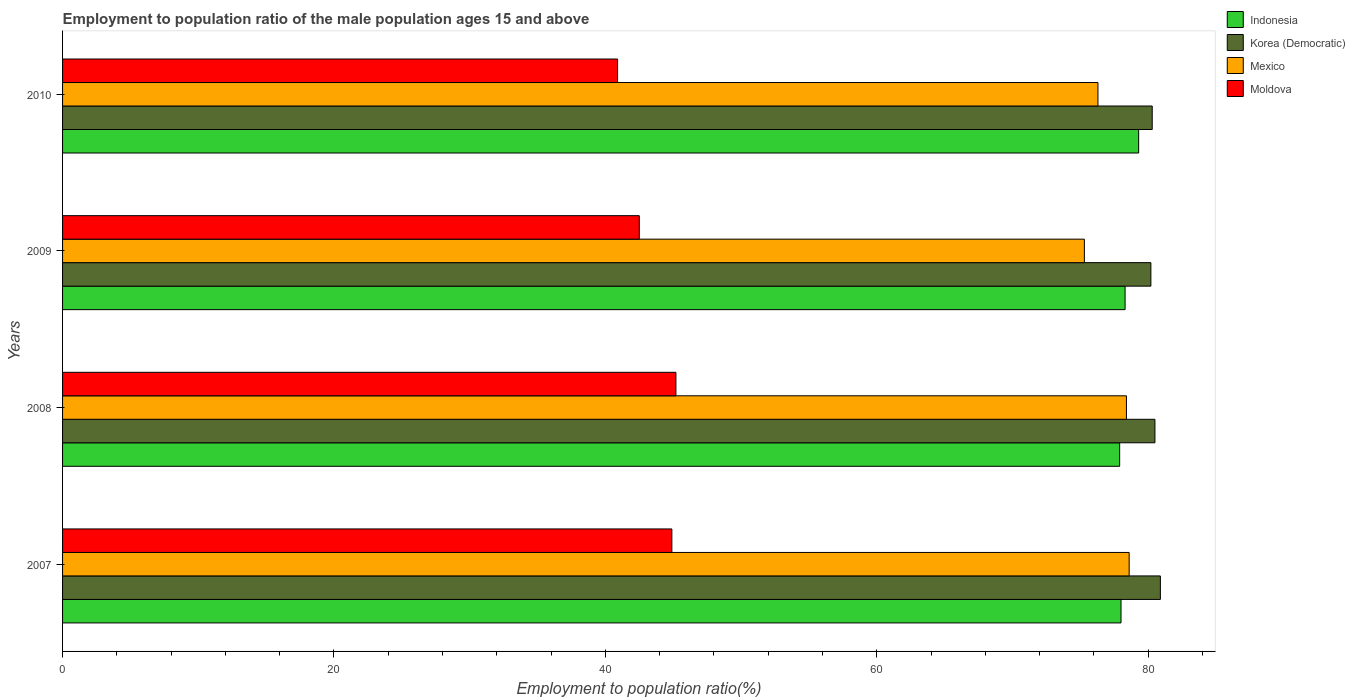How many different coloured bars are there?
Ensure brevity in your answer.  4. How many groups of bars are there?
Make the answer very short. 4. Are the number of bars per tick equal to the number of legend labels?
Give a very brief answer. Yes. Are the number of bars on each tick of the Y-axis equal?
Offer a terse response. Yes. How many bars are there on the 4th tick from the top?
Your answer should be compact. 4. How many bars are there on the 1st tick from the bottom?
Give a very brief answer. 4. In how many cases, is the number of bars for a given year not equal to the number of legend labels?
Make the answer very short. 0. What is the employment to population ratio in Indonesia in 2010?
Make the answer very short. 79.3. Across all years, what is the maximum employment to population ratio in Indonesia?
Ensure brevity in your answer.  79.3. Across all years, what is the minimum employment to population ratio in Mexico?
Provide a short and direct response. 75.3. In which year was the employment to population ratio in Korea (Democratic) maximum?
Your response must be concise. 2007. What is the total employment to population ratio in Moldova in the graph?
Offer a very short reply. 173.5. What is the difference between the employment to population ratio in Korea (Democratic) in 2007 and that in 2009?
Your answer should be compact. 0.7. What is the difference between the employment to population ratio in Mexico in 2010 and the employment to population ratio in Moldova in 2009?
Make the answer very short. 33.8. What is the average employment to population ratio in Mexico per year?
Make the answer very short. 77.15. In the year 2008, what is the difference between the employment to population ratio in Indonesia and employment to population ratio in Mexico?
Offer a terse response. -0.5. What is the ratio of the employment to population ratio in Moldova in 2008 to that in 2009?
Ensure brevity in your answer.  1.06. Is the difference between the employment to population ratio in Indonesia in 2007 and 2008 greater than the difference between the employment to population ratio in Mexico in 2007 and 2008?
Provide a short and direct response. No. What is the difference between the highest and the second highest employment to population ratio in Korea (Democratic)?
Give a very brief answer. 0.4. What is the difference between the highest and the lowest employment to population ratio in Moldova?
Your response must be concise. 4.3. What does the 1st bar from the top in 2007 represents?
Offer a very short reply. Moldova. What does the 3rd bar from the bottom in 2010 represents?
Your answer should be compact. Mexico. How many bars are there?
Give a very brief answer. 16. Are all the bars in the graph horizontal?
Offer a very short reply. Yes. What is the difference between two consecutive major ticks on the X-axis?
Your answer should be very brief. 20. Where does the legend appear in the graph?
Offer a very short reply. Top right. How many legend labels are there?
Keep it short and to the point. 4. How are the legend labels stacked?
Offer a very short reply. Vertical. What is the title of the graph?
Give a very brief answer. Employment to population ratio of the male population ages 15 and above. What is the label or title of the Y-axis?
Provide a short and direct response. Years. What is the Employment to population ratio(%) in Indonesia in 2007?
Offer a terse response. 78. What is the Employment to population ratio(%) of Korea (Democratic) in 2007?
Offer a terse response. 80.9. What is the Employment to population ratio(%) of Mexico in 2007?
Ensure brevity in your answer.  78.6. What is the Employment to population ratio(%) of Moldova in 2007?
Provide a short and direct response. 44.9. What is the Employment to population ratio(%) in Indonesia in 2008?
Ensure brevity in your answer.  77.9. What is the Employment to population ratio(%) in Korea (Democratic) in 2008?
Ensure brevity in your answer.  80.5. What is the Employment to population ratio(%) of Mexico in 2008?
Make the answer very short. 78.4. What is the Employment to population ratio(%) of Moldova in 2008?
Provide a succinct answer. 45.2. What is the Employment to population ratio(%) of Indonesia in 2009?
Offer a very short reply. 78.3. What is the Employment to population ratio(%) of Korea (Democratic) in 2009?
Offer a very short reply. 80.2. What is the Employment to population ratio(%) in Mexico in 2009?
Provide a short and direct response. 75.3. What is the Employment to population ratio(%) of Moldova in 2009?
Offer a terse response. 42.5. What is the Employment to population ratio(%) of Indonesia in 2010?
Your response must be concise. 79.3. What is the Employment to population ratio(%) in Korea (Democratic) in 2010?
Your answer should be compact. 80.3. What is the Employment to population ratio(%) in Mexico in 2010?
Keep it short and to the point. 76.3. What is the Employment to population ratio(%) in Moldova in 2010?
Ensure brevity in your answer.  40.9. Across all years, what is the maximum Employment to population ratio(%) in Indonesia?
Make the answer very short. 79.3. Across all years, what is the maximum Employment to population ratio(%) of Korea (Democratic)?
Your answer should be compact. 80.9. Across all years, what is the maximum Employment to population ratio(%) in Mexico?
Your answer should be very brief. 78.6. Across all years, what is the maximum Employment to population ratio(%) of Moldova?
Your answer should be very brief. 45.2. Across all years, what is the minimum Employment to population ratio(%) of Indonesia?
Ensure brevity in your answer.  77.9. Across all years, what is the minimum Employment to population ratio(%) of Korea (Democratic)?
Make the answer very short. 80.2. Across all years, what is the minimum Employment to population ratio(%) in Mexico?
Provide a succinct answer. 75.3. Across all years, what is the minimum Employment to population ratio(%) in Moldova?
Offer a terse response. 40.9. What is the total Employment to population ratio(%) of Indonesia in the graph?
Keep it short and to the point. 313.5. What is the total Employment to population ratio(%) in Korea (Democratic) in the graph?
Give a very brief answer. 321.9. What is the total Employment to population ratio(%) of Mexico in the graph?
Give a very brief answer. 308.6. What is the total Employment to population ratio(%) of Moldova in the graph?
Your response must be concise. 173.5. What is the difference between the Employment to population ratio(%) in Korea (Democratic) in 2007 and that in 2009?
Offer a very short reply. 0.7. What is the difference between the Employment to population ratio(%) in Mexico in 2007 and that in 2009?
Your answer should be compact. 3.3. What is the difference between the Employment to population ratio(%) of Korea (Democratic) in 2007 and that in 2010?
Your answer should be very brief. 0.6. What is the difference between the Employment to population ratio(%) in Moldova in 2007 and that in 2010?
Provide a short and direct response. 4. What is the difference between the Employment to population ratio(%) of Korea (Democratic) in 2008 and that in 2009?
Provide a short and direct response. 0.3. What is the difference between the Employment to population ratio(%) in Moldova in 2008 and that in 2009?
Keep it short and to the point. 2.7. What is the difference between the Employment to population ratio(%) of Korea (Democratic) in 2008 and that in 2010?
Ensure brevity in your answer.  0.2. What is the difference between the Employment to population ratio(%) of Moldova in 2008 and that in 2010?
Provide a succinct answer. 4.3. What is the difference between the Employment to population ratio(%) in Korea (Democratic) in 2009 and that in 2010?
Offer a terse response. -0.1. What is the difference between the Employment to population ratio(%) in Mexico in 2009 and that in 2010?
Offer a very short reply. -1. What is the difference between the Employment to population ratio(%) of Indonesia in 2007 and the Employment to population ratio(%) of Mexico in 2008?
Your answer should be compact. -0.4. What is the difference between the Employment to population ratio(%) of Indonesia in 2007 and the Employment to population ratio(%) of Moldova in 2008?
Your answer should be compact. 32.8. What is the difference between the Employment to population ratio(%) of Korea (Democratic) in 2007 and the Employment to population ratio(%) of Mexico in 2008?
Your response must be concise. 2.5. What is the difference between the Employment to population ratio(%) of Korea (Democratic) in 2007 and the Employment to population ratio(%) of Moldova in 2008?
Offer a very short reply. 35.7. What is the difference between the Employment to population ratio(%) in Mexico in 2007 and the Employment to population ratio(%) in Moldova in 2008?
Keep it short and to the point. 33.4. What is the difference between the Employment to population ratio(%) of Indonesia in 2007 and the Employment to population ratio(%) of Mexico in 2009?
Your answer should be very brief. 2.7. What is the difference between the Employment to population ratio(%) in Indonesia in 2007 and the Employment to population ratio(%) in Moldova in 2009?
Your answer should be compact. 35.5. What is the difference between the Employment to population ratio(%) in Korea (Democratic) in 2007 and the Employment to population ratio(%) in Moldova in 2009?
Ensure brevity in your answer.  38.4. What is the difference between the Employment to population ratio(%) of Mexico in 2007 and the Employment to population ratio(%) of Moldova in 2009?
Provide a succinct answer. 36.1. What is the difference between the Employment to population ratio(%) of Indonesia in 2007 and the Employment to population ratio(%) of Korea (Democratic) in 2010?
Your response must be concise. -2.3. What is the difference between the Employment to population ratio(%) of Indonesia in 2007 and the Employment to population ratio(%) of Moldova in 2010?
Your answer should be very brief. 37.1. What is the difference between the Employment to population ratio(%) in Mexico in 2007 and the Employment to population ratio(%) in Moldova in 2010?
Your response must be concise. 37.7. What is the difference between the Employment to population ratio(%) in Indonesia in 2008 and the Employment to population ratio(%) in Korea (Democratic) in 2009?
Your answer should be compact. -2.3. What is the difference between the Employment to population ratio(%) in Indonesia in 2008 and the Employment to population ratio(%) in Mexico in 2009?
Offer a terse response. 2.6. What is the difference between the Employment to population ratio(%) in Indonesia in 2008 and the Employment to population ratio(%) in Moldova in 2009?
Ensure brevity in your answer.  35.4. What is the difference between the Employment to population ratio(%) in Korea (Democratic) in 2008 and the Employment to population ratio(%) in Moldova in 2009?
Offer a very short reply. 38. What is the difference between the Employment to population ratio(%) of Mexico in 2008 and the Employment to population ratio(%) of Moldova in 2009?
Your answer should be very brief. 35.9. What is the difference between the Employment to population ratio(%) of Indonesia in 2008 and the Employment to population ratio(%) of Mexico in 2010?
Keep it short and to the point. 1.6. What is the difference between the Employment to population ratio(%) in Indonesia in 2008 and the Employment to population ratio(%) in Moldova in 2010?
Give a very brief answer. 37. What is the difference between the Employment to population ratio(%) in Korea (Democratic) in 2008 and the Employment to population ratio(%) in Mexico in 2010?
Offer a very short reply. 4.2. What is the difference between the Employment to population ratio(%) in Korea (Democratic) in 2008 and the Employment to population ratio(%) in Moldova in 2010?
Provide a succinct answer. 39.6. What is the difference between the Employment to population ratio(%) in Mexico in 2008 and the Employment to population ratio(%) in Moldova in 2010?
Ensure brevity in your answer.  37.5. What is the difference between the Employment to population ratio(%) in Indonesia in 2009 and the Employment to population ratio(%) in Moldova in 2010?
Your answer should be compact. 37.4. What is the difference between the Employment to population ratio(%) of Korea (Democratic) in 2009 and the Employment to population ratio(%) of Mexico in 2010?
Offer a terse response. 3.9. What is the difference between the Employment to population ratio(%) of Korea (Democratic) in 2009 and the Employment to population ratio(%) of Moldova in 2010?
Your answer should be very brief. 39.3. What is the difference between the Employment to population ratio(%) of Mexico in 2009 and the Employment to population ratio(%) of Moldova in 2010?
Offer a very short reply. 34.4. What is the average Employment to population ratio(%) in Indonesia per year?
Provide a short and direct response. 78.38. What is the average Employment to population ratio(%) in Korea (Democratic) per year?
Provide a short and direct response. 80.47. What is the average Employment to population ratio(%) of Mexico per year?
Give a very brief answer. 77.15. What is the average Employment to population ratio(%) of Moldova per year?
Ensure brevity in your answer.  43.38. In the year 2007, what is the difference between the Employment to population ratio(%) in Indonesia and Employment to population ratio(%) in Korea (Democratic)?
Give a very brief answer. -2.9. In the year 2007, what is the difference between the Employment to population ratio(%) in Indonesia and Employment to population ratio(%) in Moldova?
Provide a succinct answer. 33.1. In the year 2007, what is the difference between the Employment to population ratio(%) of Korea (Democratic) and Employment to population ratio(%) of Mexico?
Provide a short and direct response. 2.3. In the year 2007, what is the difference between the Employment to population ratio(%) in Mexico and Employment to population ratio(%) in Moldova?
Offer a terse response. 33.7. In the year 2008, what is the difference between the Employment to population ratio(%) in Indonesia and Employment to population ratio(%) in Mexico?
Provide a succinct answer. -0.5. In the year 2008, what is the difference between the Employment to population ratio(%) of Indonesia and Employment to population ratio(%) of Moldova?
Ensure brevity in your answer.  32.7. In the year 2008, what is the difference between the Employment to population ratio(%) in Korea (Democratic) and Employment to population ratio(%) in Moldova?
Ensure brevity in your answer.  35.3. In the year 2008, what is the difference between the Employment to population ratio(%) in Mexico and Employment to population ratio(%) in Moldova?
Make the answer very short. 33.2. In the year 2009, what is the difference between the Employment to population ratio(%) of Indonesia and Employment to population ratio(%) of Mexico?
Offer a very short reply. 3. In the year 2009, what is the difference between the Employment to population ratio(%) in Indonesia and Employment to population ratio(%) in Moldova?
Keep it short and to the point. 35.8. In the year 2009, what is the difference between the Employment to population ratio(%) of Korea (Democratic) and Employment to population ratio(%) of Moldova?
Offer a terse response. 37.7. In the year 2009, what is the difference between the Employment to population ratio(%) in Mexico and Employment to population ratio(%) in Moldova?
Provide a short and direct response. 32.8. In the year 2010, what is the difference between the Employment to population ratio(%) in Indonesia and Employment to population ratio(%) in Korea (Democratic)?
Give a very brief answer. -1. In the year 2010, what is the difference between the Employment to population ratio(%) of Indonesia and Employment to population ratio(%) of Mexico?
Offer a very short reply. 3. In the year 2010, what is the difference between the Employment to population ratio(%) in Indonesia and Employment to population ratio(%) in Moldova?
Ensure brevity in your answer.  38.4. In the year 2010, what is the difference between the Employment to population ratio(%) in Korea (Democratic) and Employment to population ratio(%) in Mexico?
Ensure brevity in your answer.  4. In the year 2010, what is the difference between the Employment to population ratio(%) of Korea (Democratic) and Employment to population ratio(%) of Moldova?
Your response must be concise. 39.4. In the year 2010, what is the difference between the Employment to population ratio(%) of Mexico and Employment to population ratio(%) of Moldova?
Your response must be concise. 35.4. What is the ratio of the Employment to population ratio(%) in Indonesia in 2007 to that in 2008?
Your answer should be compact. 1. What is the ratio of the Employment to population ratio(%) of Indonesia in 2007 to that in 2009?
Offer a very short reply. 1. What is the ratio of the Employment to population ratio(%) in Korea (Democratic) in 2007 to that in 2009?
Your answer should be very brief. 1.01. What is the ratio of the Employment to population ratio(%) in Mexico in 2007 to that in 2009?
Keep it short and to the point. 1.04. What is the ratio of the Employment to population ratio(%) in Moldova in 2007 to that in 2009?
Provide a succinct answer. 1.06. What is the ratio of the Employment to population ratio(%) of Indonesia in 2007 to that in 2010?
Make the answer very short. 0.98. What is the ratio of the Employment to population ratio(%) in Korea (Democratic) in 2007 to that in 2010?
Provide a succinct answer. 1.01. What is the ratio of the Employment to population ratio(%) in Mexico in 2007 to that in 2010?
Make the answer very short. 1.03. What is the ratio of the Employment to population ratio(%) in Moldova in 2007 to that in 2010?
Provide a succinct answer. 1.1. What is the ratio of the Employment to population ratio(%) of Korea (Democratic) in 2008 to that in 2009?
Ensure brevity in your answer.  1. What is the ratio of the Employment to population ratio(%) of Mexico in 2008 to that in 2009?
Make the answer very short. 1.04. What is the ratio of the Employment to population ratio(%) in Moldova in 2008 to that in 2009?
Provide a succinct answer. 1.06. What is the ratio of the Employment to population ratio(%) of Indonesia in 2008 to that in 2010?
Provide a succinct answer. 0.98. What is the ratio of the Employment to population ratio(%) in Korea (Democratic) in 2008 to that in 2010?
Your response must be concise. 1. What is the ratio of the Employment to population ratio(%) of Mexico in 2008 to that in 2010?
Provide a succinct answer. 1.03. What is the ratio of the Employment to population ratio(%) in Moldova in 2008 to that in 2010?
Make the answer very short. 1.11. What is the ratio of the Employment to population ratio(%) in Indonesia in 2009 to that in 2010?
Your answer should be very brief. 0.99. What is the ratio of the Employment to population ratio(%) of Korea (Democratic) in 2009 to that in 2010?
Make the answer very short. 1. What is the ratio of the Employment to population ratio(%) of Mexico in 2009 to that in 2010?
Offer a terse response. 0.99. What is the ratio of the Employment to population ratio(%) of Moldova in 2009 to that in 2010?
Offer a very short reply. 1.04. What is the difference between the highest and the second highest Employment to population ratio(%) of Mexico?
Provide a succinct answer. 0.2. What is the difference between the highest and the lowest Employment to population ratio(%) of Indonesia?
Provide a succinct answer. 1.4. What is the difference between the highest and the lowest Employment to population ratio(%) in Mexico?
Make the answer very short. 3.3. What is the difference between the highest and the lowest Employment to population ratio(%) of Moldova?
Offer a terse response. 4.3. 